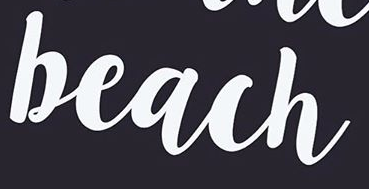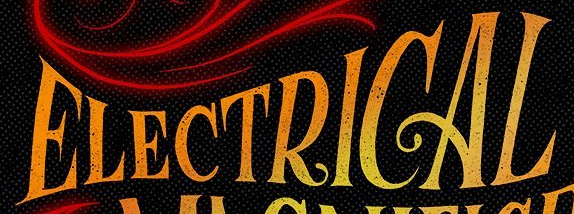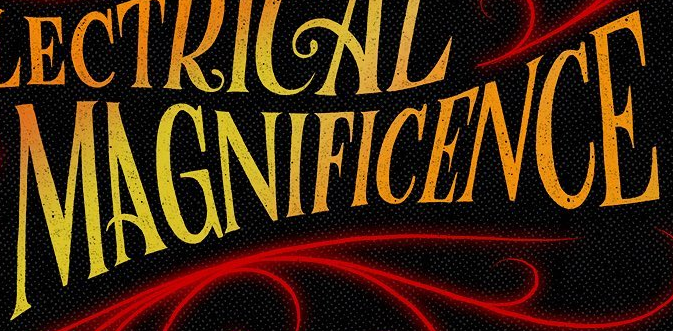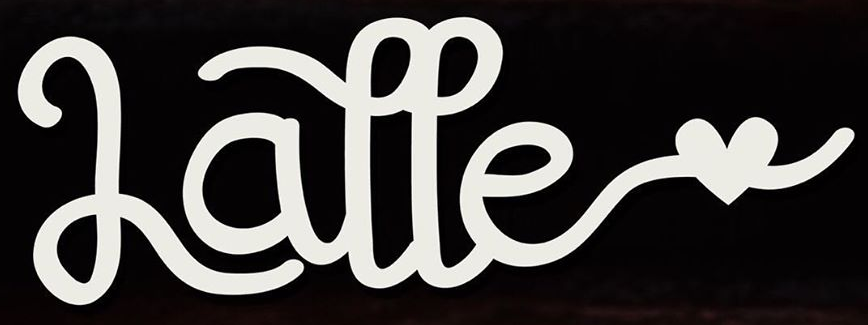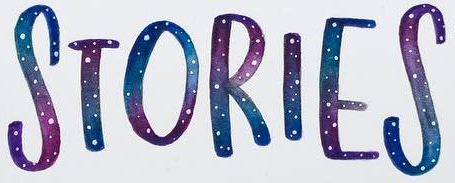Transcribe the words shown in these images in order, separated by a semicolon. beach; ELECTRICAL; MAGNIFICENCE; Latte; STORIES 